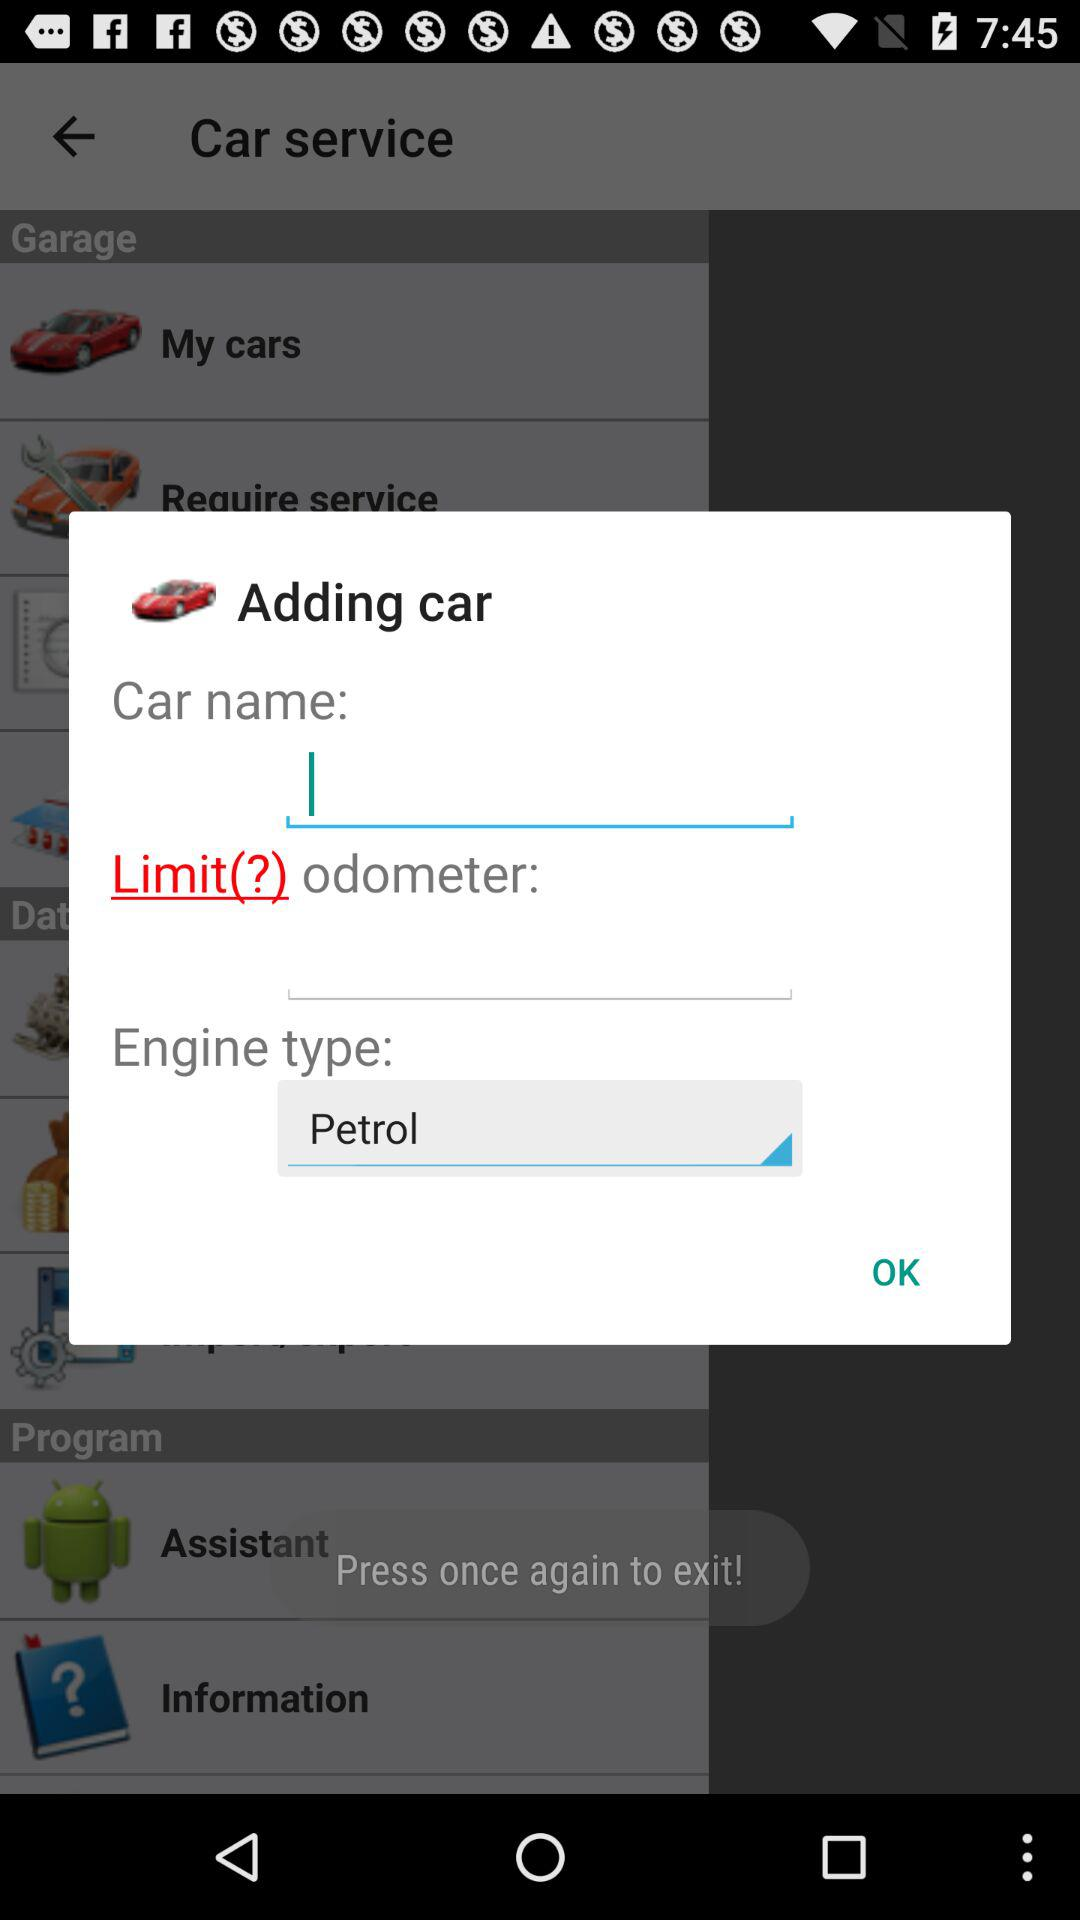How many fields are there for adding a car?
Answer the question using a single word or phrase. 3 